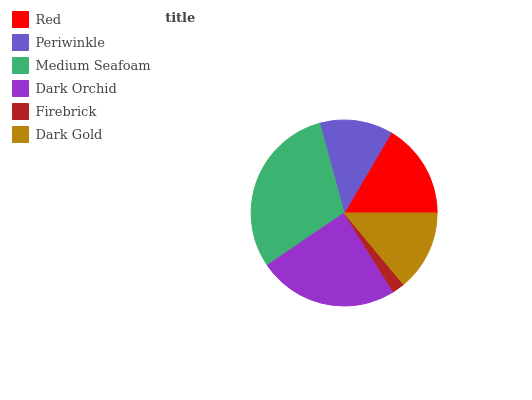Is Firebrick the minimum?
Answer yes or no. Yes. Is Medium Seafoam the maximum?
Answer yes or no. Yes. Is Periwinkle the minimum?
Answer yes or no. No. Is Periwinkle the maximum?
Answer yes or no. No. Is Red greater than Periwinkle?
Answer yes or no. Yes. Is Periwinkle less than Red?
Answer yes or no. Yes. Is Periwinkle greater than Red?
Answer yes or no. No. Is Red less than Periwinkle?
Answer yes or no. No. Is Red the high median?
Answer yes or no. Yes. Is Dark Gold the low median?
Answer yes or no. Yes. Is Dark Orchid the high median?
Answer yes or no. No. Is Periwinkle the low median?
Answer yes or no. No. 